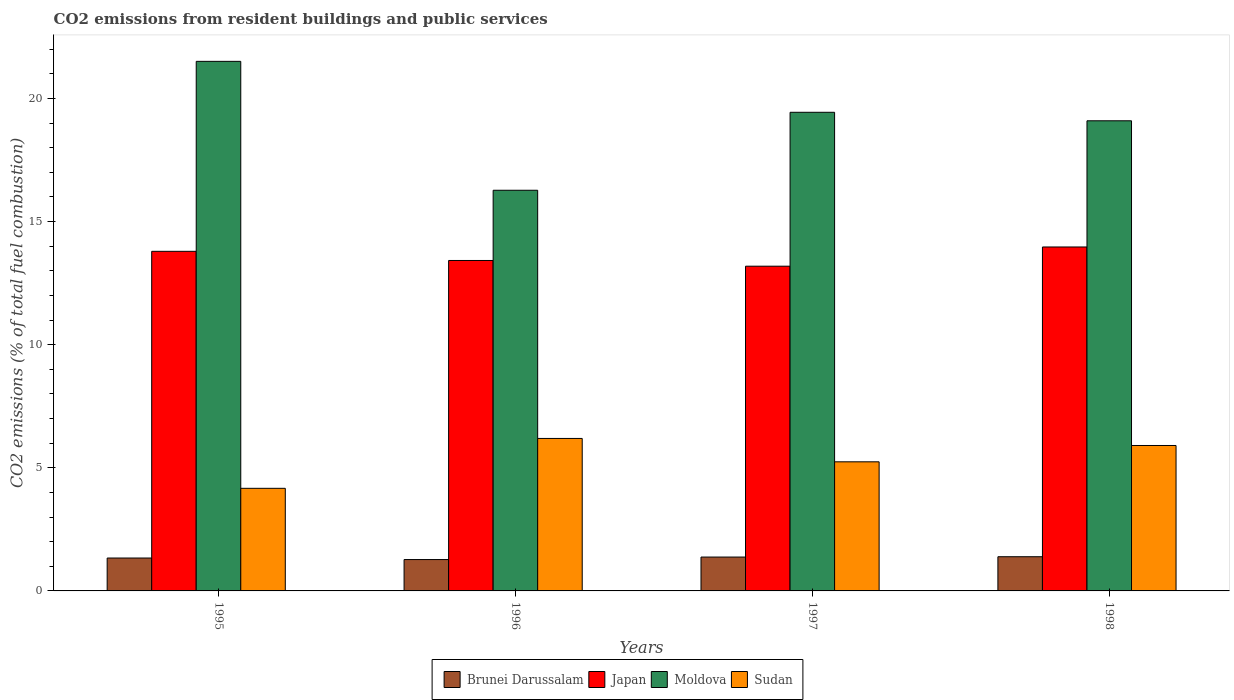Are the number of bars per tick equal to the number of legend labels?
Your response must be concise. Yes. Are the number of bars on each tick of the X-axis equal?
Your answer should be compact. Yes. How many bars are there on the 1st tick from the left?
Make the answer very short. 4. How many bars are there on the 4th tick from the right?
Provide a succinct answer. 4. What is the label of the 1st group of bars from the left?
Offer a terse response. 1995. In how many cases, is the number of bars for a given year not equal to the number of legend labels?
Offer a terse response. 0. What is the total CO2 emitted in Japan in 1995?
Offer a terse response. 13.79. Across all years, what is the maximum total CO2 emitted in Brunei Darussalam?
Make the answer very short. 1.39. Across all years, what is the minimum total CO2 emitted in Japan?
Offer a terse response. 13.19. In which year was the total CO2 emitted in Sudan minimum?
Ensure brevity in your answer.  1995. What is the total total CO2 emitted in Brunei Darussalam in the graph?
Your answer should be very brief. 5.37. What is the difference between the total CO2 emitted in Brunei Darussalam in 1996 and that in 1998?
Make the answer very short. -0.12. What is the difference between the total CO2 emitted in Japan in 1997 and the total CO2 emitted in Sudan in 1995?
Offer a very short reply. 9.02. What is the average total CO2 emitted in Brunei Darussalam per year?
Make the answer very short. 1.34. In the year 1995, what is the difference between the total CO2 emitted in Moldova and total CO2 emitted in Japan?
Offer a very short reply. 7.72. What is the ratio of the total CO2 emitted in Sudan in 1996 to that in 1997?
Give a very brief answer. 1.18. Is the total CO2 emitted in Sudan in 1996 less than that in 1997?
Your response must be concise. No. Is the difference between the total CO2 emitted in Moldova in 1995 and 1998 greater than the difference between the total CO2 emitted in Japan in 1995 and 1998?
Provide a succinct answer. Yes. What is the difference between the highest and the second highest total CO2 emitted in Japan?
Your answer should be very brief. 0.18. What is the difference between the highest and the lowest total CO2 emitted in Sudan?
Keep it short and to the point. 2.03. Is the sum of the total CO2 emitted in Japan in 1995 and 1997 greater than the maximum total CO2 emitted in Moldova across all years?
Your answer should be very brief. Yes. What does the 3rd bar from the left in 1995 represents?
Your answer should be compact. Moldova. What does the 4th bar from the right in 1996 represents?
Keep it short and to the point. Brunei Darussalam. Is it the case that in every year, the sum of the total CO2 emitted in Moldova and total CO2 emitted in Brunei Darussalam is greater than the total CO2 emitted in Japan?
Offer a very short reply. Yes. What is the difference between two consecutive major ticks on the Y-axis?
Offer a very short reply. 5. Are the values on the major ticks of Y-axis written in scientific E-notation?
Make the answer very short. No. Does the graph contain grids?
Your answer should be very brief. No. What is the title of the graph?
Your answer should be very brief. CO2 emissions from resident buildings and public services. Does "Lebanon" appear as one of the legend labels in the graph?
Provide a succinct answer. No. What is the label or title of the X-axis?
Offer a very short reply. Years. What is the label or title of the Y-axis?
Give a very brief answer. CO2 emissions (% of total fuel combustion). What is the CO2 emissions (% of total fuel combustion) in Brunei Darussalam in 1995?
Give a very brief answer. 1.34. What is the CO2 emissions (% of total fuel combustion) in Japan in 1995?
Ensure brevity in your answer.  13.79. What is the CO2 emissions (% of total fuel combustion) in Moldova in 1995?
Keep it short and to the point. 21.51. What is the CO2 emissions (% of total fuel combustion) in Sudan in 1995?
Provide a short and direct response. 4.17. What is the CO2 emissions (% of total fuel combustion) in Brunei Darussalam in 1996?
Your answer should be very brief. 1.27. What is the CO2 emissions (% of total fuel combustion) in Japan in 1996?
Provide a succinct answer. 13.42. What is the CO2 emissions (% of total fuel combustion) in Moldova in 1996?
Offer a very short reply. 16.27. What is the CO2 emissions (% of total fuel combustion) in Sudan in 1996?
Keep it short and to the point. 6.19. What is the CO2 emissions (% of total fuel combustion) of Brunei Darussalam in 1997?
Your answer should be compact. 1.38. What is the CO2 emissions (% of total fuel combustion) in Japan in 1997?
Ensure brevity in your answer.  13.19. What is the CO2 emissions (% of total fuel combustion) in Moldova in 1997?
Keep it short and to the point. 19.44. What is the CO2 emissions (% of total fuel combustion) of Sudan in 1997?
Make the answer very short. 5.24. What is the CO2 emissions (% of total fuel combustion) of Brunei Darussalam in 1998?
Keep it short and to the point. 1.39. What is the CO2 emissions (% of total fuel combustion) in Japan in 1998?
Provide a short and direct response. 13.97. What is the CO2 emissions (% of total fuel combustion) in Moldova in 1998?
Your response must be concise. 19.09. What is the CO2 emissions (% of total fuel combustion) of Sudan in 1998?
Your response must be concise. 5.91. Across all years, what is the maximum CO2 emissions (% of total fuel combustion) in Brunei Darussalam?
Provide a short and direct response. 1.39. Across all years, what is the maximum CO2 emissions (% of total fuel combustion) in Japan?
Offer a very short reply. 13.97. Across all years, what is the maximum CO2 emissions (% of total fuel combustion) of Moldova?
Provide a succinct answer. 21.51. Across all years, what is the maximum CO2 emissions (% of total fuel combustion) in Sudan?
Ensure brevity in your answer.  6.19. Across all years, what is the minimum CO2 emissions (% of total fuel combustion) of Brunei Darussalam?
Your answer should be compact. 1.27. Across all years, what is the minimum CO2 emissions (% of total fuel combustion) in Japan?
Offer a terse response. 13.19. Across all years, what is the minimum CO2 emissions (% of total fuel combustion) of Moldova?
Your response must be concise. 16.27. Across all years, what is the minimum CO2 emissions (% of total fuel combustion) of Sudan?
Your response must be concise. 4.17. What is the total CO2 emissions (% of total fuel combustion) of Brunei Darussalam in the graph?
Offer a terse response. 5.37. What is the total CO2 emissions (% of total fuel combustion) of Japan in the graph?
Offer a very short reply. 54.37. What is the total CO2 emissions (% of total fuel combustion) of Moldova in the graph?
Provide a succinct answer. 76.31. What is the total CO2 emissions (% of total fuel combustion) in Sudan in the graph?
Give a very brief answer. 21.51. What is the difference between the CO2 emissions (% of total fuel combustion) in Brunei Darussalam in 1995 and that in 1996?
Provide a succinct answer. 0.06. What is the difference between the CO2 emissions (% of total fuel combustion) in Japan in 1995 and that in 1996?
Keep it short and to the point. 0.37. What is the difference between the CO2 emissions (% of total fuel combustion) of Moldova in 1995 and that in 1996?
Offer a terse response. 5.24. What is the difference between the CO2 emissions (% of total fuel combustion) of Sudan in 1995 and that in 1996?
Keep it short and to the point. -2.03. What is the difference between the CO2 emissions (% of total fuel combustion) in Brunei Darussalam in 1995 and that in 1997?
Keep it short and to the point. -0.04. What is the difference between the CO2 emissions (% of total fuel combustion) of Japan in 1995 and that in 1997?
Offer a very short reply. 0.6. What is the difference between the CO2 emissions (% of total fuel combustion) of Moldova in 1995 and that in 1997?
Provide a succinct answer. 2.07. What is the difference between the CO2 emissions (% of total fuel combustion) of Sudan in 1995 and that in 1997?
Offer a very short reply. -1.08. What is the difference between the CO2 emissions (% of total fuel combustion) of Brunei Darussalam in 1995 and that in 1998?
Make the answer very short. -0.05. What is the difference between the CO2 emissions (% of total fuel combustion) in Japan in 1995 and that in 1998?
Provide a succinct answer. -0.18. What is the difference between the CO2 emissions (% of total fuel combustion) of Moldova in 1995 and that in 1998?
Provide a succinct answer. 2.41. What is the difference between the CO2 emissions (% of total fuel combustion) in Sudan in 1995 and that in 1998?
Your response must be concise. -1.74. What is the difference between the CO2 emissions (% of total fuel combustion) of Brunei Darussalam in 1996 and that in 1997?
Offer a very short reply. -0.1. What is the difference between the CO2 emissions (% of total fuel combustion) of Japan in 1996 and that in 1997?
Your answer should be compact. 0.23. What is the difference between the CO2 emissions (% of total fuel combustion) in Moldova in 1996 and that in 1997?
Offer a terse response. -3.17. What is the difference between the CO2 emissions (% of total fuel combustion) in Sudan in 1996 and that in 1997?
Offer a terse response. 0.95. What is the difference between the CO2 emissions (% of total fuel combustion) in Brunei Darussalam in 1996 and that in 1998?
Ensure brevity in your answer.  -0.12. What is the difference between the CO2 emissions (% of total fuel combustion) in Japan in 1996 and that in 1998?
Offer a terse response. -0.55. What is the difference between the CO2 emissions (% of total fuel combustion) in Moldova in 1996 and that in 1998?
Your answer should be compact. -2.82. What is the difference between the CO2 emissions (% of total fuel combustion) in Sudan in 1996 and that in 1998?
Your answer should be very brief. 0.29. What is the difference between the CO2 emissions (% of total fuel combustion) in Brunei Darussalam in 1997 and that in 1998?
Your answer should be compact. -0.01. What is the difference between the CO2 emissions (% of total fuel combustion) in Japan in 1997 and that in 1998?
Your response must be concise. -0.78. What is the difference between the CO2 emissions (% of total fuel combustion) in Moldova in 1997 and that in 1998?
Make the answer very short. 0.35. What is the difference between the CO2 emissions (% of total fuel combustion) of Sudan in 1997 and that in 1998?
Your answer should be very brief. -0.66. What is the difference between the CO2 emissions (% of total fuel combustion) in Brunei Darussalam in 1995 and the CO2 emissions (% of total fuel combustion) in Japan in 1996?
Your answer should be compact. -12.08. What is the difference between the CO2 emissions (% of total fuel combustion) of Brunei Darussalam in 1995 and the CO2 emissions (% of total fuel combustion) of Moldova in 1996?
Offer a terse response. -14.94. What is the difference between the CO2 emissions (% of total fuel combustion) in Brunei Darussalam in 1995 and the CO2 emissions (% of total fuel combustion) in Sudan in 1996?
Your answer should be compact. -4.86. What is the difference between the CO2 emissions (% of total fuel combustion) in Japan in 1995 and the CO2 emissions (% of total fuel combustion) in Moldova in 1996?
Offer a terse response. -2.48. What is the difference between the CO2 emissions (% of total fuel combustion) in Japan in 1995 and the CO2 emissions (% of total fuel combustion) in Sudan in 1996?
Offer a very short reply. 7.6. What is the difference between the CO2 emissions (% of total fuel combustion) in Moldova in 1995 and the CO2 emissions (% of total fuel combustion) in Sudan in 1996?
Ensure brevity in your answer.  15.31. What is the difference between the CO2 emissions (% of total fuel combustion) of Brunei Darussalam in 1995 and the CO2 emissions (% of total fuel combustion) of Japan in 1997?
Make the answer very short. -11.85. What is the difference between the CO2 emissions (% of total fuel combustion) in Brunei Darussalam in 1995 and the CO2 emissions (% of total fuel combustion) in Moldova in 1997?
Provide a short and direct response. -18.1. What is the difference between the CO2 emissions (% of total fuel combustion) of Brunei Darussalam in 1995 and the CO2 emissions (% of total fuel combustion) of Sudan in 1997?
Your answer should be very brief. -3.91. What is the difference between the CO2 emissions (% of total fuel combustion) of Japan in 1995 and the CO2 emissions (% of total fuel combustion) of Moldova in 1997?
Offer a very short reply. -5.65. What is the difference between the CO2 emissions (% of total fuel combustion) of Japan in 1995 and the CO2 emissions (% of total fuel combustion) of Sudan in 1997?
Offer a very short reply. 8.55. What is the difference between the CO2 emissions (% of total fuel combustion) in Moldova in 1995 and the CO2 emissions (% of total fuel combustion) in Sudan in 1997?
Your answer should be very brief. 16.26. What is the difference between the CO2 emissions (% of total fuel combustion) in Brunei Darussalam in 1995 and the CO2 emissions (% of total fuel combustion) in Japan in 1998?
Give a very brief answer. -12.63. What is the difference between the CO2 emissions (% of total fuel combustion) in Brunei Darussalam in 1995 and the CO2 emissions (% of total fuel combustion) in Moldova in 1998?
Your answer should be compact. -17.76. What is the difference between the CO2 emissions (% of total fuel combustion) in Brunei Darussalam in 1995 and the CO2 emissions (% of total fuel combustion) in Sudan in 1998?
Offer a very short reply. -4.57. What is the difference between the CO2 emissions (% of total fuel combustion) in Japan in 1995 and the CO2 emissions (% of total fuel combustion) in Moldova in 1998?
Keep it short and to the point. -5.3. What is the difference between the CO2 emissions (% of total fuel combustion) of Japan in 1995 and the CO2 emissions (% of total fuel combustion) of Sudan in 1998?
Keep it short and to the point. 7.89. What is the difference between the CO2 emissions (% of total fuel combustion) in Moldova in 1995 and the CO2 emissions (% of total fuel combustion) in Sudan in 1998?
Provide a short and direct response. 15.6. What is the difference between the CO2 emissions (% of total fuel combustion) of Brunei Darussalam in 1996 and the CO2 emissions (% of total fuel combustion) of Japan in 1997?
Keep it short and to the point. -11.91. What is the difference between the CO2 emissions (% of total fuel combustion) of Brunei Darussalam in 1996 and the CO2 emissions (% of total fuel combustion) of Moldova in 1997?
Offer a terse response. -18.16. What is the difference between the CO2 emissions (% of total fuel combustion) of Brunei Darussalam in 1996 and the CO2 emissions (% of total fuel combustion) of Sudan in 1997?
Provide a succinct answer. -3.97. What is the difference between the CO2 emissions (% of total fuel combustion) of Japan in 1996 and the CO2 emissions (% of total fuel combustion) of Moldova in 1997?
Your answer should be compact. -6.02. What is the difference between the CO2 emissions (% of total fuel combustion) of Japan in 1996 and the CO2 emissions (% of total fuel combustion) of Sudan in 1997?
Ensure brevity in your answer.  8.18. What is the difference between the CO2 emissions (% of total fuel combustion) in Moldova in 1996 and the CO2 emissions (% of total fuel combustion) in Sudan in 1997?
Your response must be concise. 11.03. What is the difference between the CO2 emissions (% of total fuel combustion) in Brunei Darussalam in 1996 and the CO2 emissions (% of total fuel combustion) in Japan in 1998?
Your answer should be compact. -12.69. What is the difference between the CO2 emissions (% of total fuel combustion) in Brunei Darussalam in 1996 and the CO2 emissions (% of total fuel combustion) in Moldova in 1998?
Your answer should be compact. -17.82. What is the difference between the CO2 emissions (% of total fuel combustion) in Brunei Darussalam in 1996 and the CO2 emissions (% of total fuel combustion) in Sudan in 1998?
Your answer should be very brief. -4.63. What is the difference between the CO2 emissions (% of total fuel combustion) of Japan in 1996 and the CO2 emissions (% of total fuel combustion) of Moldova in 1998?
Make the answer very short. -5.67. What is the difference between the CO2 emissions (% of total fuel combustion) of Japan in 1996 and the CO2 emissions (% of total fuel combustion) of Sudan in 1998?
Provide a succinct answer. 7.51. What is the difference between the CO2 emissions (% of total fuel combustion) of Moldova in 1996 and the CO2 emissions (% of total fuel combustion) of Sudan in 1998?
Give a very brief answer. 10.37. What is the difference between the CO2 emissions (% of total fuel combustion) in Brunei Darussalam in 1997 and the CO2 emissions (% of total fuel combustion) in Japan in 1998?
Your answer should be very brief. -12.59. What is the difference between the CO2 emissions (% of total fuel combustion) in Brunei Darussalam in 1997 and the CO2 emissions (% of total fuel combustion) in Moldova in 1998?
Provide a short and direct response. -17.72. What is the difference between the CO2 emissions (% of total fuel combustion) in Brunei Darussalam in 1997 and the CO2 emissions (% of total fuel combustion) in Sudan in 1998?
Your response must be concise. -4.53. What is the difference between the CO2 emissions (% of total fuel combustion) of Japan in 1997 and the CO2 emissions (% of total fuel combustion) of Moldova in 1998?
Provide a short and direct response. -5.91. What is the difference between the CO2 emissions (% of total fuel combustion) of Japan in 1997 and the CO2 emissions (% of total fuel combustion) of Sudan in 1998?
Your answer should be compact. 7.28. What is the difference between the CO2 emissions (% of total fuel combustion) in Moldova in 1997 and the CO2 emissions (% of total fuel combustion) in Sudan in 1998?
Make the answer very short. 13.53. What is the average CO2 emissions (% of total fuel combustion) in Brunei Darussalam per year?
Ensure brevity in your answer.  1.34. What is the average CO2 emissions (% of total fuel combustion) of Japan per year?
Offer a terse response. 13.59. What is the average CO2 emissions (% of total fuel combustion) of Moldova per year?
Provide a succinct answer. 19.08. What is the average CO2 emissions (% of total fuel combustion) of Sudan per year?
Offer a terse response. 5.38. In the year 1995, what is the difference between the CO2 emissions (% of total fuel combustion) of Brunei Darussalam and CO2 emissions (% of total fuel combustion) of Japan?
Your answer should be compact. -12.46. In the year 1995, what is the difference between the CO2 emissions (% of total fuel combustion) of Brunei Darussalam and CO2 emissions (% of total fuel combustion) of Moldova?
Provide a short and direct response. -20.17. In the year 1995, what is the difference between the CO2 emissions (% of total fuel combustion) of Brunei Darussalam and CO2 emissions (% of total fuel combustion) of Sudan?
Make the answer very short. -2.83. In the year 1995, what is the difference between the CO2 emissions (% of total fuel combustion) in Japan and CO2 emissions (% of total fuel combustion) in Moldova?
Make the answer very short. -7.72. In the year 1995, what is the difference between the CO2 emissions (% of total fuel combustion) of Japan and CO2 emissions (% of total fuel combustion) of Sudan?
Your answer should be compact. 9.63. In the year 1995, what is the difference between the CO2 emissions (% of total fuel combustion) in Moldova and CO2 emissions (% of total fuel combustion) in Sudan?
Offer a terse response. 17.34. In the year 1996, what is the difference between the CO2 emissions (% of total fuel combustion) in Brunei Darussalam and CO2 emissions (% of total fuel combustion) in Japan?
Provide a succinct answer. -12.15. In the year 1996, what is the difference between the CO2 emissions (% of total fuel combustion) of Brunei Darussalam and CO2 emissions (% of total fuel combustion) of Moldova?
Offer a terse response. -15. In the year 1996, what is the difference between the CO2 emissions (% of total fuel combustion) of Brunei Darussalam and CO2 emissions (% of total fuel combustion) of Sudan?
Make the answer very short. -4.92. In the year 1996, what is the difference between the CO2 emissions (% of total fuel combustion) in Japan and CO2 emissions (% of total fuel combustion) in Moldova?
Your answer should be compact. -2.85. In the year 1996, what is the difference between the CO2 emissions (% of total fuel combustion) in Japan and CO2 emissions (% of total fuel combustion) in Sudan?
Make the answer very short. 7.23. In the year 1996, what is the difference between the CO2 emissions (% of total fuel combustion) in Moldova and CO2 emissions (% of total fuel combustion) in Sudan?
Keep it short and to the point. 10.08. In the year 1997, what is the difference between the CO2 emissions (% of total fuel combustion) of Brunei Darussalam and CO2 emissions (% of total fuel combustion) of Japan?
Ensure brevity in your answer.  -11.81. In the year 1997, what is the difference between the CO2 emissions (% of total fuel combustion) of Brunei Darussalam and CO2 emissions (% of total fuel combustion) of Moldova?
Ensure brevity in your answer.  -18.06. In the year 1997, what is the difference between the CO2 emissions (% of total fuel combustion) in Brunei Darussalam and CO2 emissions (% of total fuel combustion) in Sudan?
Provide a short and direct response. -3.87. In the year 1997, what is the difference between the CO2 emissions (% of total fuel combustion) of Japan and CO2 emissions (% of total fuel combustion) of Moldova?
Provide a short and direct response. -6.25. In the year 1997, what is the difference between the CO2 emissions (% of total fuel combustion) of Japan and CO2 emissions (% of total fuel combustion) of Sudan?
Keep it short and to the point. 7.94. In the year 1997, what is the difference between the CO2 emissions (% of total fuel combustion) of Moldova and CO2 emissions (% of total fuel combustion) of Sudan?
Ensure brevity in your answer.  14.2. In the year 1998, what is the difference between the CO2 emissions (% of total fuel combustion) of Brunei Darussalam and CO2 emissions (% of total fuel combustion) of Japan?
Ensure brevity in your answer.  -12.58. In the year 1998, what is the difference between the CO2 emissions (% of total fuel combustion) in Brunei Darussalam and CO2 emissions (% of total fuel combustion) in Moldova?
Provide a short and direct response. -17.7. In the year 1998, what is the difference between the CO2 emissions (% of total fuel combustion) of Brunei Darussalam and CO2 emissions (% of total fuel combustion) of Sudan?
Provide a short and direct response. -4.52. In the year 1998, what is the difference between the CO2 emissions (% of total fuel combustion) of Japan and CO2 emissions (% of total fuel combustion) of Moldova?
Your answer should be very brief. -5.12. In the year 1998, what is the difference between the CO2 emissions (% of total fuel combustion) in Japan and CO2 emissions (% of total fuel combustion) in Sudan?
Keep it short and to the point. 8.06. In the year 1998, what is the difference between the CO2 emissions (% of total fuel combustion) of Moldova and CO2 emissions (% of total fuel combustion) of Sudan?
Your answer should be compact. 13.19. What is the ratio of the CO2 emissions (% of total fuel combustion) in Brunei Darussalam in 1995 to that in 1996?
Offer a terse response. 1.05. What is the ratio of the CO2 emissions (% of total fuel combustion) of Japan in 1995 to that in 1996?
Offer a very short reply. 1.03. What is the ratio of the CO2 emissions (% of total fuel combustion) of Moldova in 1995 to that in 1996?
Provide a short and direct response. 1.32. What is the ratio of the CO2 emissions (% of total fuel combustion) in Sudan in 1995 to that in 1996?
Make the answer very short. 0.67. What is the ratio of the CO2 emissions (% of total fuel combustion) of Brunei Darussalam in 1995 to that in 1997?
Ensure brevity in your answer.  0.97. What is the ratio of the CO2 emissions (% of total fuel combustion) of Japan in 1995 to that in 1997?
Your response must be concise. 1.05. What is the ratio of the CO2 emissions (% of total fuel combustion) of Moldova in 1995 to that in 1997?
Offer a very short reply. 1.11. What is the ratio of the CO2 emissions (% of total fuel combustion) in Sudan in 1995 to that in 1997?
Keep it short and to the point. 0.79. What is the ratio of the CO2 emissions (% of total fuel combustion) in Brunei Darussalam in 1995 to that in 1998?
Your response must be concise. 0.96. What is the ratio of the CO2 emissions (% of total fuel combustion) in Japan in 1995 to that in 1998?
Provide a succinct answer. 0.99. What is the ratio of the CO2 emissions (% of total fuel combustion) of Moldova in 1995 to that in 1998?
Keep it short and to the point. 1.13. What is the ratio of the CO2 emissions (% of total fuel combustion) of Sudan in 1995 to that in 1998?
Give a very brief answer. 0.71. What is the ratio of the CO2 emissions (% of total fuel combustion) in Brunei Darussalam in 1996 to that in 1997?
Offer a very short reply. 0.93. What is the ratio of the CO2 emissions (% of total fuel combustion) in Japan in 1996 to that in 1997?
Your answer should be very brief. 1.02. What is the ratio of the CO2 emissions (% of total fuel combustion) in Moldova in 1996 to that in 1997?
Your answer should be very brief. 0.84. What is the ratio of the CO2 emissions (% of total fuel combustion) in Sudan in 1996 to that in 1997?
Make the answer very short. 1.18. What is the ratio of the CO2 emissions (% of total fuel combustion) in Brunei Darussalam in 1996 to that in 1998?
Your answer should be compact. 0.92. What is the ratio of the CO2 emissions (% of total fuel combustion) of Japan in 1996 to that in 1998?
Offer a terse response. 0.96. What is the ratio of the CO2 emissions (% of total fuel combustion) in Moldova in 1996 to that in 1998?
Offer a very short reply. 0.85. What is the ratio of the CO2 emissions (% of total fuel combustion) of Sudan in 1996 to that in 1998?
Provide a short and direct response. 1.05. What is the ratio of the CO2 emissions (% of total fuel combustion) in Brunei Darussalam in 1997 to that in 1998?
Make the answer very short. 0.99. What is the ratio of the CO2 emissions (% of total fuel combustion) in Japan in 1997 to that in 1998?
Offer a terse response. 0.94. What is the ratio of the CO2 emissions (% of total fuel combustion) of Moldova in 1997 to that in 1998?
Your answer should be very brief. 1.02. What is the ratio of the CO2 emissions (% of total fuel combustion) in Sudan in 1997 to that in 1998?
Your answer should be very brief. 0.89. What is the difference between the highest and the second highest CO2 emissions (% of total fuel combustion) in Brunei Darussalam?
Offer a terse response. 0.01. What is the difference between the highest and the second highest CO2 emissions (% of total fuel combustion) in Japan?
Give a very brief answer. 0.18. What is the difference between the highest and the second highest CO2 emissions (% of total fuel combustion) of Moldova?
Make the answer very short. 2.07. What is the difference between the highest and the second highest CO2 emissions (% of total fuel combustion) of Sudan?
Keep it short and to the point. 0.29. What is the difference between the highest and the lowest CO2 emissions (% of total fuel combustion) of Brunei Darussalam?
Your answer should be very brief. 0.12. What is the difference between the highest and the lowest CO2 emissions (% of total fuel combustion) in Japan?
Your response must be concise. 0.78. What is the difference between the highest and the lowest CO2 emissions (% of total fuel combustion) in Moldova?
Offer a terse response. 5.24. What is the difference between the highest and the lowest CO2 emissions (% of total fuel combustion) in Sudan?
Your response must be concise. 2.03. 